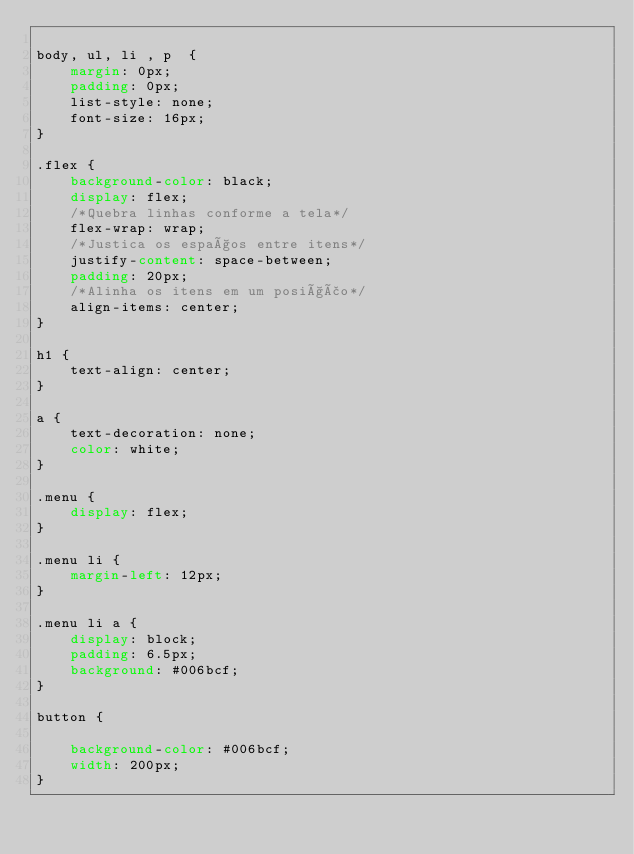Convert code to text. <code><loc_0><loc_0><loc_500><loc_500><_CSS_>
body, ul, li , p  {
    margin: 0px;
    padding: 0px;
    list-style: none;
    font-size: 16px;
}

.flex {
    background-color: black;
    display: flex;
    /*Quebra linhas conforme a tela*/
    flex-wrap: wrap;
    /*Justica os espaços entre itens*/
    justify-content: space-between;
    padding: 20px;
    /*Alinha os itens em um posição*/
    align-items: center;
}

h1 {
    text-align: center;
}

a {
    text-decoration: none;
    color: white;
}

.menu {
    display: flex;
}

.menu li {
    margin-left: 12px;
}

.menu li a {
    display: block;
    padding: 6.5px;
    background: #006bcf;
}

button {
    
    background-color: #006bcf;
    width: 200px;
}


</code> 